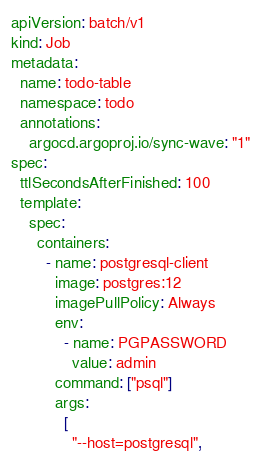<code> <loc_0><loc_0><loc_500><loc_500><_YAML_>apiVersion: batch/v1
kind: Job
metadata:
  name: todo-table
  namespace: todo
  annotations:
    argocd.argoproj.io/sync-wave: "1"
spec:
  ttlSecondsAfterFinished: 100
  template:
    spec:
      containers:
        - name: postgresql-client
          image: postgres:12
          imagePullPolicy: Always
          env:
            - name: PGPASSWORD
              value: admin
          command: ["psql"]
          args:
            [
              "--host=postgresql",</code> 